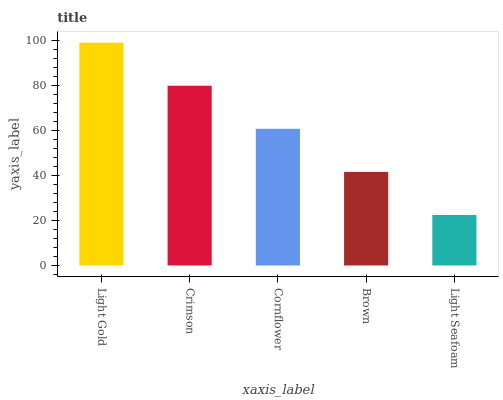Is Light Seafoam the minimum?
Answer yes or no. Yes. Is Light Gold the maximum?
Answer yes or no. Yes. Is Crimson the minimum?
Answer yes or no. No. Is Crimson the maximum?
Answer yes or no. No. Is Light Gold greater than Crimson?
Answer yes or no. Yes. Is Crimson less than Light Gold?
Answer yes or no. Yes. Is Crimson greater than Light Gold?
Answer yes or no. No. Is Light Gold less than Crimson?
Answer yes or no. No. Is Cornflower the high median?
Answer yes or no. Yes. Is Cornflower the low median?
Answer yes or no. Yes. Is Light Gold the high median?
Answer yes or no. No. Is Light Seafoam the low median?
Answer yes or no. No. 